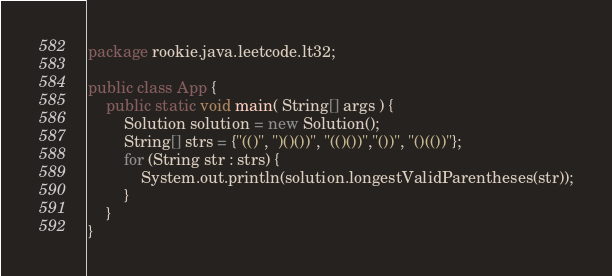<code> <loc_0><loc_0><loc_500><loc_500><_Java_>package rookie.java.leetcode.lt32;

public class App {
    public static void main( String[] args ) {
    	Solution solution = new Solution();
    	String[] strs = {"(()", ")()())", "(()())","())", "()(())"};
    	for (String str : strs) {
    		System.out.println(solution.longestValidParentheses(str));
    	}
    }
}
</code> 